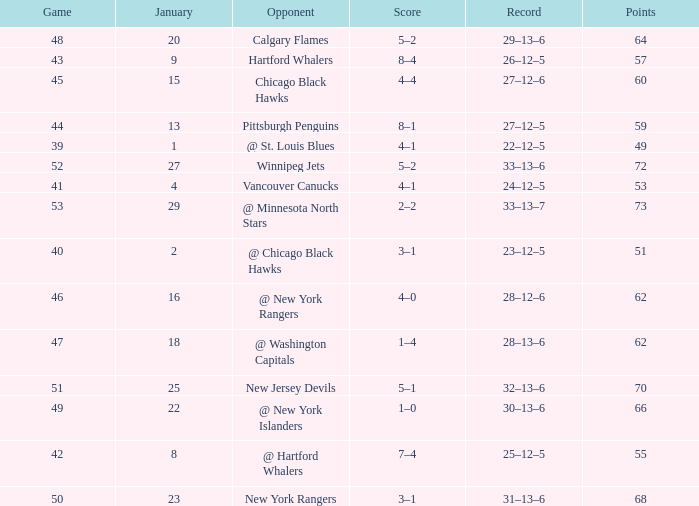How many games have a Score of 1–0, and Points smaller than 66? 0.0. Can you give me this table as a dict? {'header': ['Game', 'January', 'Opponent', 'Score', 'Record', 'Points'], 'rows': [['48', '20', 'Calgary Flames', '5–2', '29–13–6', '64'], ['43', '9', 'Hartford Whalers', '8–4', '26–12–5', '57'], ['45', '15', 'Chicago Black Hawks', '4–4', '27–12–6', '60'], ['44', '13', 'Pittsburgh Penguins', '8–1', '27–12–5', '59'], ['39', '1', '@ St. Louis Blues', '4–1', '22–12–5', '49'], ['52', '27', 'Winnipeg Jets', '5–2', '33–13–6', '72'], ['41', '4', 'Vancouver Canucks', '4–1', '24–12–5', '53'], ['53', '29', '@ Minnesota North Stars', '2–2', '33–13–7', '73'], ['40', '2', '@ Chicago Black Hawks', '3–1', '23–12–5', '51'], ['46', '16', '@ New York Rangers', '4–0', '28–12–6', '62'], ['47', '18', '@ Washington Capitals', '1–4', '28–13–6', '62'], ['51', '25', 'New Jersey Devils', '5–1', '32–13–6', '70'], ['49', '22', '@ New York Islanders', '1–0', '30–13–6', '66'], ['42', '8', '@ Hartford Whalers', '7–4', '25–12–5', '55'], ['50', '23', 'New York Rangers', '3–1', '31–13–6', '68']]} 